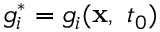<formula> <loc_0><loc_0><loc_500><loc_500>g _ { i } ^ { * } = g _ { i } ( x , \ t _ { 0 } )</formula> 